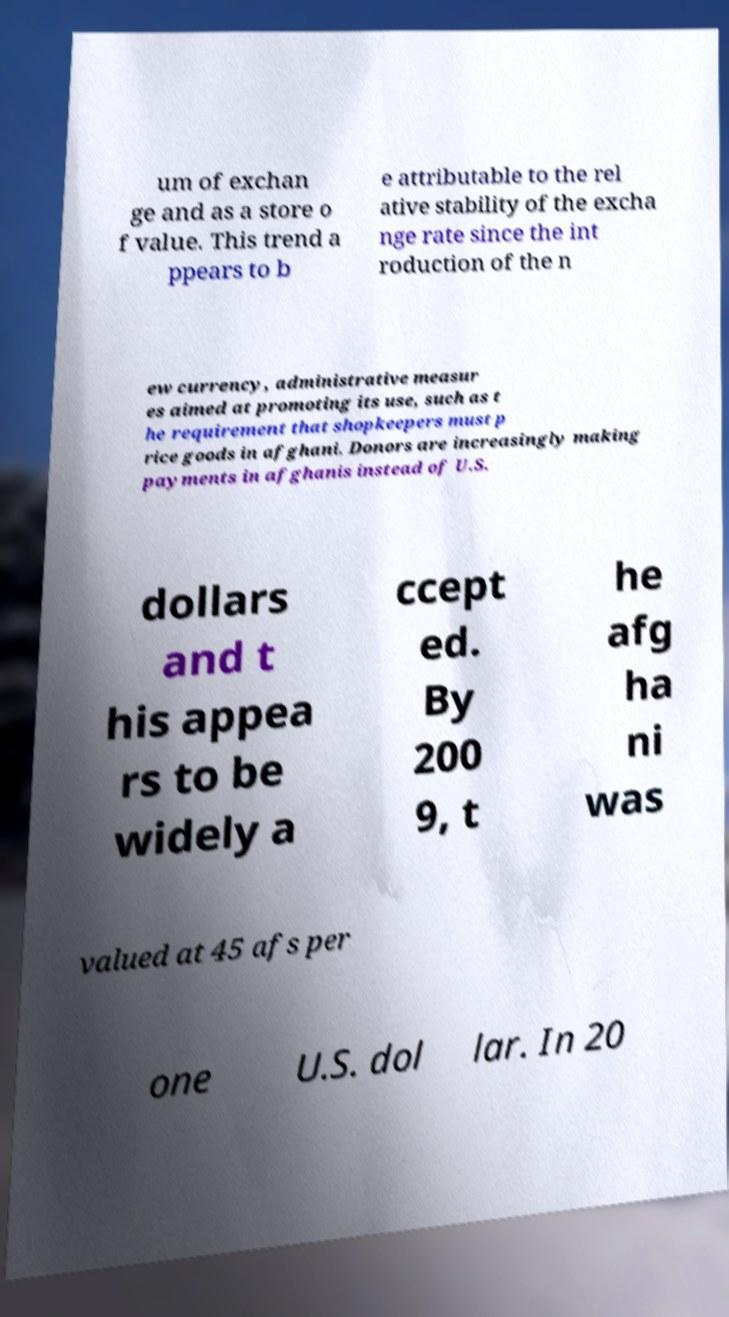Can you read and provide the text displayed in the image?This photo seems to have some interesting text. Can you extract and type it out for me? um of exchan ge and as a store o f value. This trend a ppears to b e attributable to the rel ative stability of the excha nge rate since the int roduction of the n ew currency, administrative measur es aimed at promoting its use, such as t he requirement that shopkeepers must p rice goods in afghani. Donors are increasingly making payments in afghanis instead of U.S. dollars and t his appea rs to be widely a ccept ed. By 200 9, t he afg ha ni was valued at 45 afs per one U.S. dol lar. In 20 